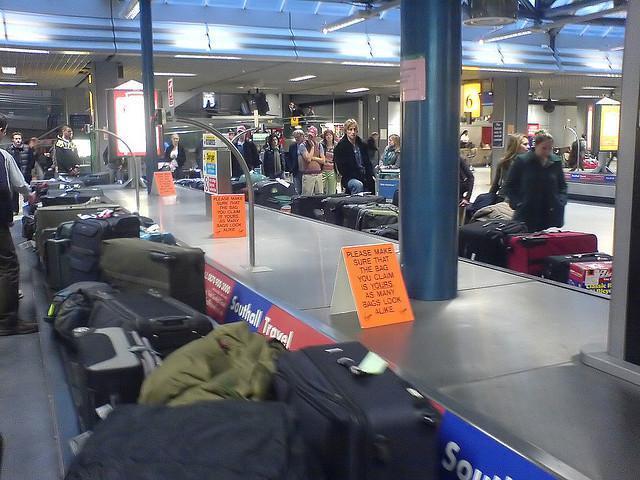How many people can you see?
Give a very brief answer. 2. How many suitcases can be seen?
Give a very brief answer. 8. How many cats are meowing on a bed?
Give a very brief answer. 0. 